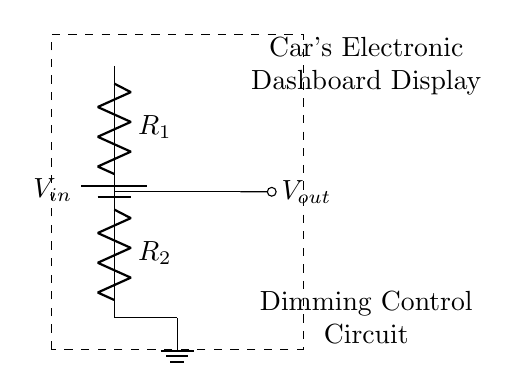What is the function of the circuit? The function of this circuit is to act as a voltage divider, which adjusts the voltage output for dimming controls on a car's electronic dashboard display.
Answer: Voltage divider What are the two resistor values in the circuit? The circuit includes two resistors, identified as R1 and R2. The exact values are not specified in the diagram, but their arrangement impacts the output voltage.
Answer: R1 and R2 Where is the output voltage taken from? The output voltage, represented as Vout, is taken from the junction of the two resistors R1 and R2, which creates a reduced voltage based on the ratio of the resistors.
Answer: Junction of R1 and R2 What is the significance of the battery in the circuit? The battery, indicated as Vin, supplies the initial voltage required for the operation of the voltage divider circuit and powers the dimming control feature.
Answer: Power supply How does changing R1 affect Vout? Increasing the resistance of R1 will result in a higher output voltage Vout, as per the voltage divider formula, which is dependent on the proportion of R1 in relation to R1 and R2 combined.
Answer: Raises Vout What is the purpose of using a voltage divider in a car dashboard display? The voltage divider serves to control the brightness of the dashboard display, allowing for visibility adjustments in various lighting conditions for optimal driver safety and comfort.
Answer: Dimming control 